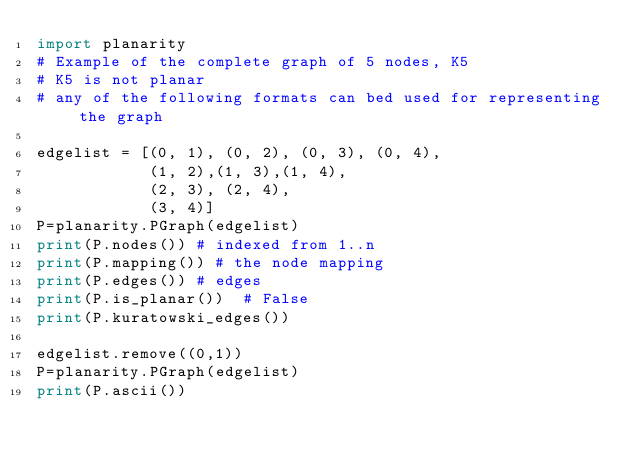Convert code to text. <code><loc_0><loc_0><loc_500><loc_500><_Python_>import planarity
# Example of the complete graph of 5 nodes, K5
# K5 is not planar
# any of the following formats can bed used for representing the graph

edgelist = [(0, 1), (0, 2), (0, 3), (0, 4),
            (1, 2),(1, 3),(1, 4),
            (2, 3), (2, 4),
            (3, 4)]
P=planarity.PGraph(edgelist)
print(P.nodes()) # indexed from 1..n
print(P.mapping()) # the node mapping
print(P.edges()) # edges
print(P.is_planar())  # False
print(P.kuratowski_edges())

edgelist.remove((0,1))
P=planarity.PGraph(edgelist)
print(P.ascii())
</code> 